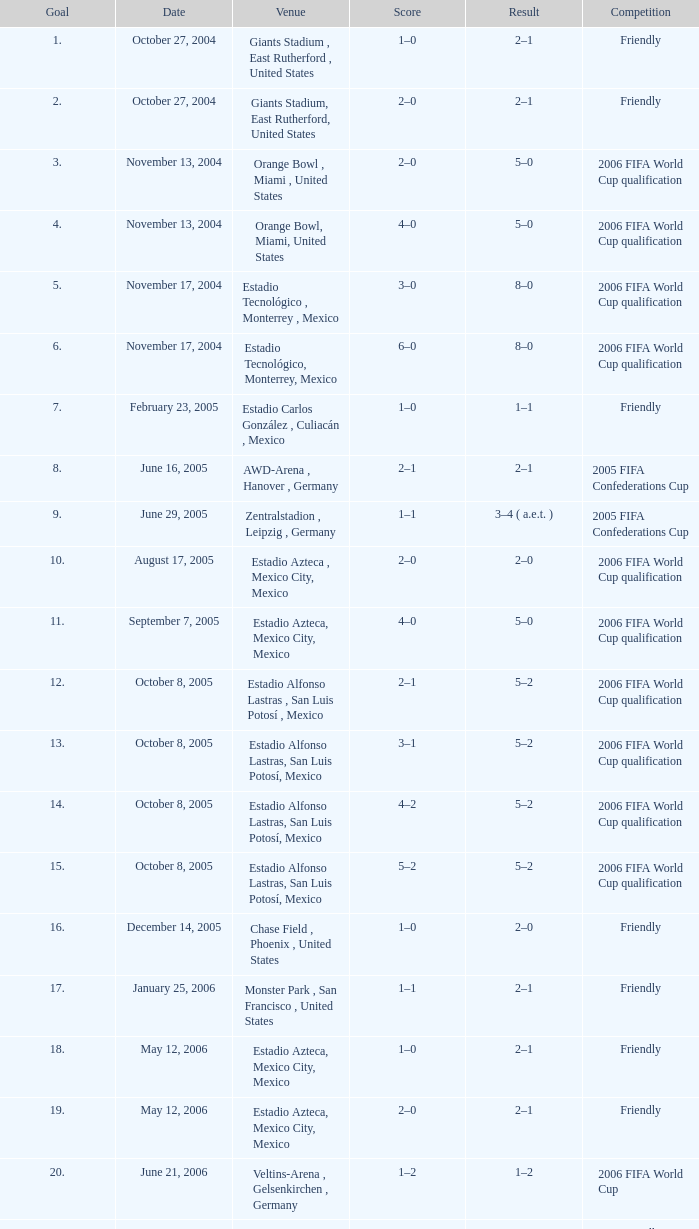Which Competition has a Venue of estadio alfonso lastras, san luis potosí, mexico, and a Goal larger than 15? Friendly. 